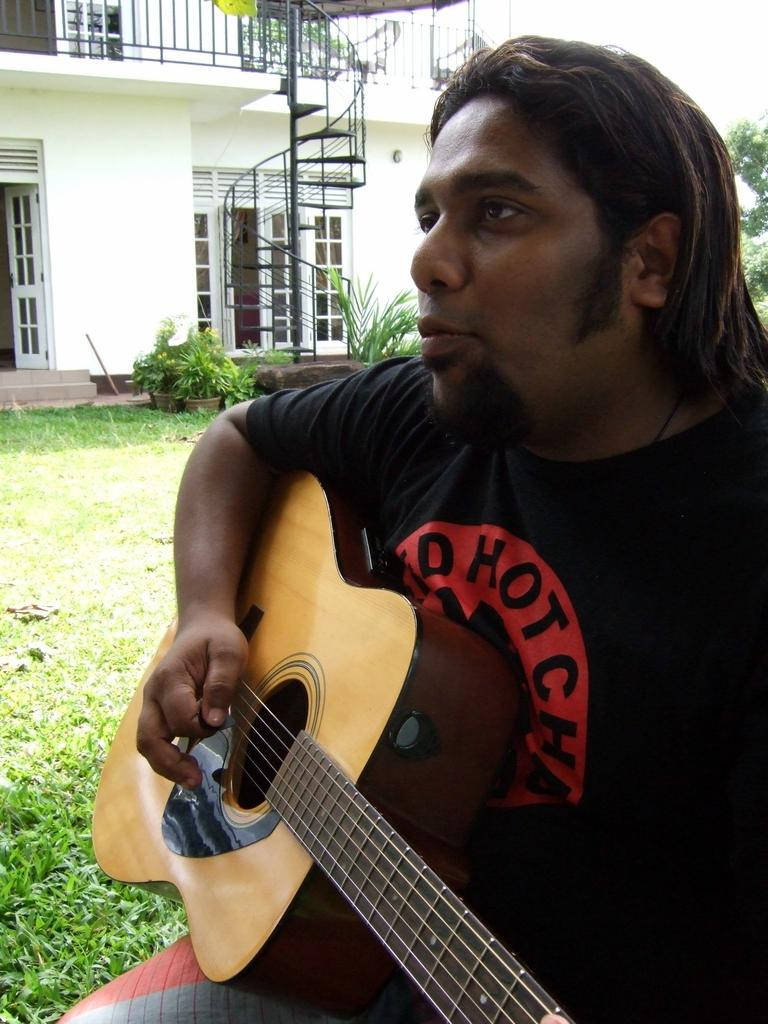What is the person in the image doing? The person is playing a guitar. Can you describe the setting in which the person is playing the guitar? There is a house and plants in the background of the image, and grass is visible in the image. What type of vegetation can be seen in the background of the image? There is a tree in the background of the image. What is the person's opinion on soda in the image? There is no information about the person's opinion on soda in the image. Can you tell me if the person's mother is present in the image? There is no information about the person's mother in the image. 